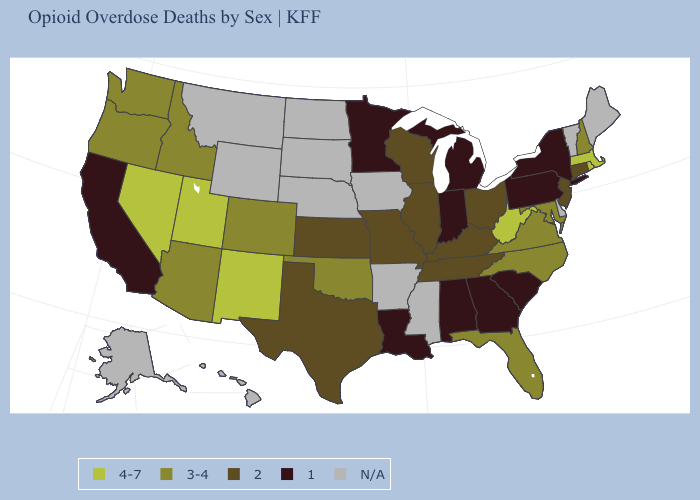What is the value of Delaware?
Answer briefly. N/A. Among the states that border Missouri , does Oklahoma have the highest value?
Concise answer only. Yes. Which states have the highest value in the USA?
Quick response, please. Massachusetts, Nevada, New Mexico, Rhode Island, Utah, West Virginia. Among the states that border Wisconsin , which have the lowest value?
Quick response, please. Michigan, Minnesota. Which states have the lowest value in the West?
Answer briefly. California. Name the states that have a value in the range N/A?
Quick response, please. Alaska, Arkansas, Delaware, Hawaii, Iowa, Maine, Mississippi, Montana, Nebraska, North Dakota, South Dakota, Vermont, Wyoming. Which states have the highest value in the USA?
Write a very short answer. Massachusetts, Nevada, New Mexico, Rhode Island, Utah, West Virginia. Does Michigan have the lowest value in the USA?
Concise answer only. Yes. Name the states that have a value in the range N/A?
Quick response, please. Alaska, Arkansas, Delaware, Hawaii, Iowa, Maine, Mississippi, Montana, Nebraska, North Dakota, South Dakota, Vermont, Wyoming. What is the value of Texas?
Answer briefly. 2. What is the lowest value in the MidWest?
Be succinct. 1. What is the value of Nebraska?
Give a very brief answer. N/A. 